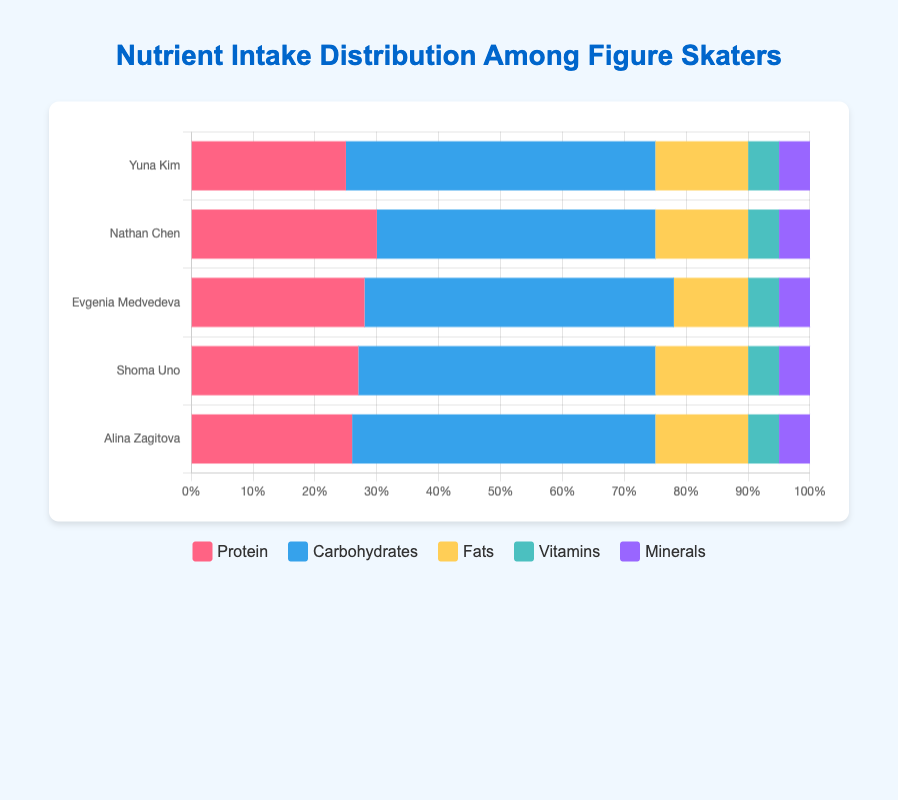What is the total carbohydrate intake for Evgenia Medvedeva and Shoma Uno combined? The carbohydrate intake for Evgenia Medvedeva is 50%, and for Shoma Uno, it's 48%. Adding these together gives 50% + 48% = 98%.
Answer: 98% Which figure skater has the highest protein intake? By comparing the protein intake of all the skaters, Nathan Chen has the highest with 30%.
Answer: Nathan Chen What is the difference in fat intake between Yuna Kim and Evgenia Medvedeva? Yuna Kim's fat intake is 15%, and Evgenia Medvedeva's fat intake is 12%. The difference is 15% - 12% = 3%.
Answer: 3% Who are the figure skaters that have an equal amount of vitamins in their diet? All the figure skaters have a vitamin intake of 5%.
Answer: All of them Compare the carbohydrate intake of Nathan Chen and Alina Zagitova. Who intakes more? Nathan Chen's carbohydrate intake is 45%, while Alina Zagitova's is 49%. Comparing these values, Alina Zagitova intakes more carbohydrates.
Answer: Alina Zagitova What percentage of Yuna Kim's nutrient intake is not carbohydrates? Yuna Kim's carbohydrate intake is 50%. The remaining percentage is 100% - 50% = 50%.
Answer: 50% Which nutrient is the third-largest portion of Shoma Uno's diet? Shoma Uno's diet is 27% protein, 48% carbohydrates, 15% fats, 5% vitamins, and 5% minerals. The third-largest portion is fats at 15%.
Answer: Fats How many figure skaters have a protein intake between 25% and 30%? Yuna Kim (25%), Nathan Chen (30%), Evgenia Medvedeva (28%), Shoma Uno (27%), and Alina Zagitova (26%) all fall in this range. There are 5 skaters.
Answer: 5 Which nutrient has the lowest intake across all figure skaters? All the figure skaters have an equal intake of vitamins and minerals at 5%.
Answer: Vitamins and Minerals What is the average protein intake of all the figure skaters? The protein intake values are 25, 30, 28, 27, and 26. The average is (25+30+28+27+26)/5 = 27.2%.
Answer: 27.2% 